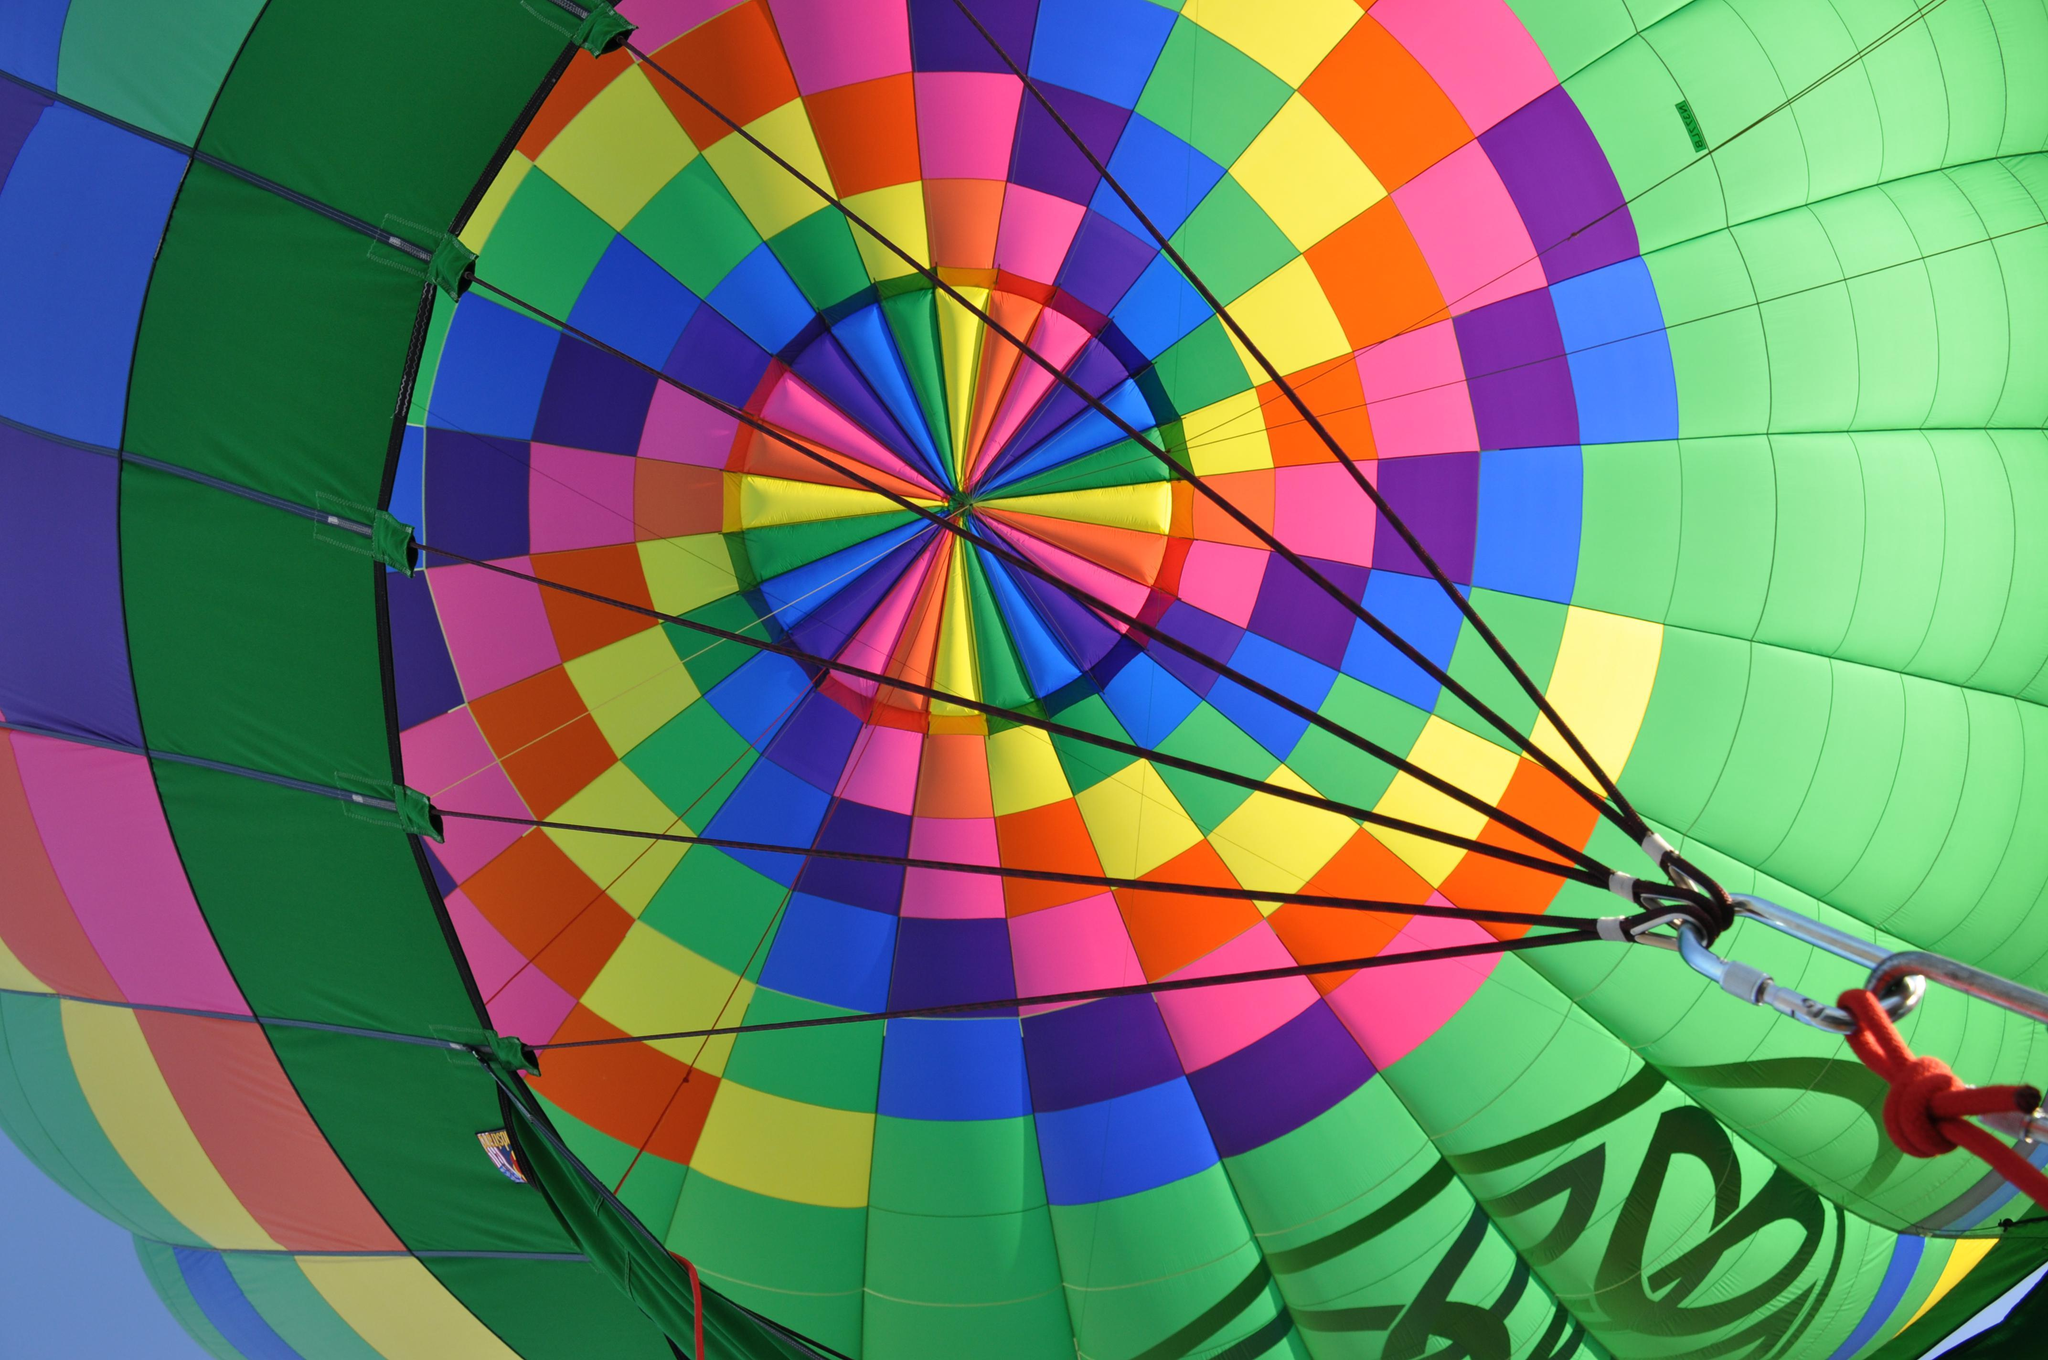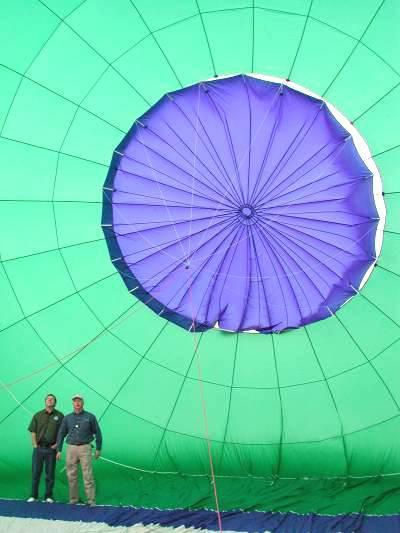The first image is the image on the left, the second image is the image on the right. Analyze the images presented: Is the assertion "The parachute in the right image contains at least four colors." valid? Answer yes or no. No. The first image is the image on the left, the second image is the image on the right. Considering the images on both sides, is "There is a person in one of the images" valid? Answer yes or no. Yes. 